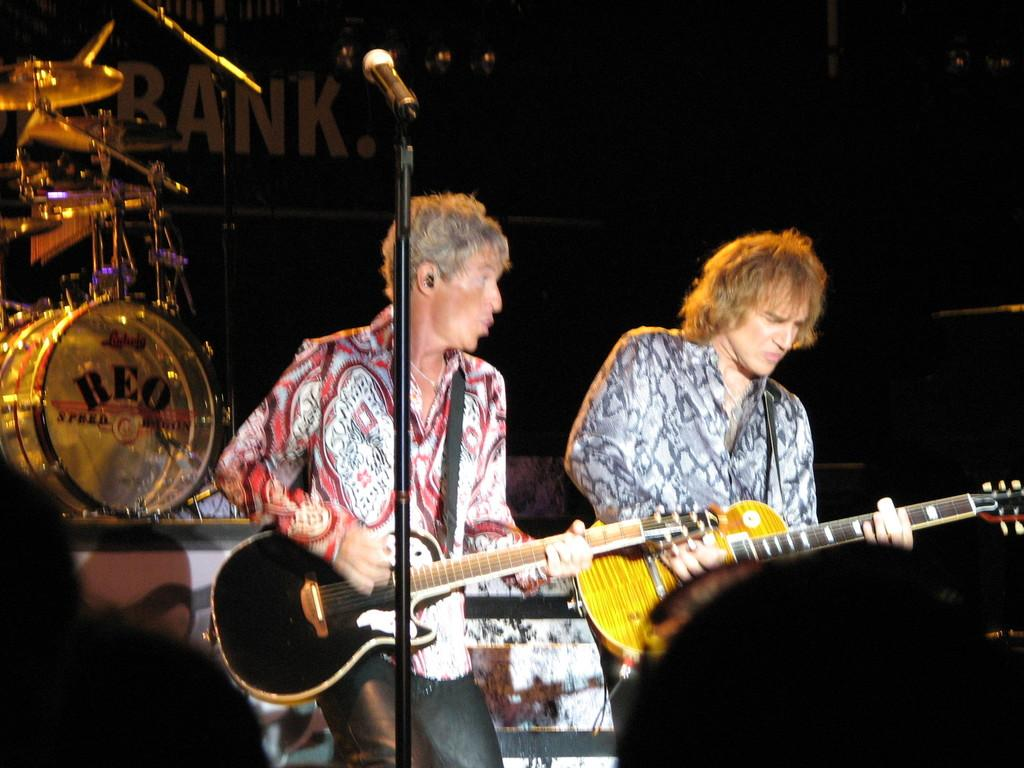What are the men in the image doing? The men in the image are playing guitars. What equipment is being used by the men? The men have microphones in front of them. What other musical instrument can be seen in the image? There are drums present in the image. What type of coal is being used to fuel the house in the image? There is no house or coal present in the image; it features men playing guitars and using microphones and drums. Can you hear the men crying while playing their instruments in the image? There is no indication of anyone crying in the image; the men are playing their instruments. 